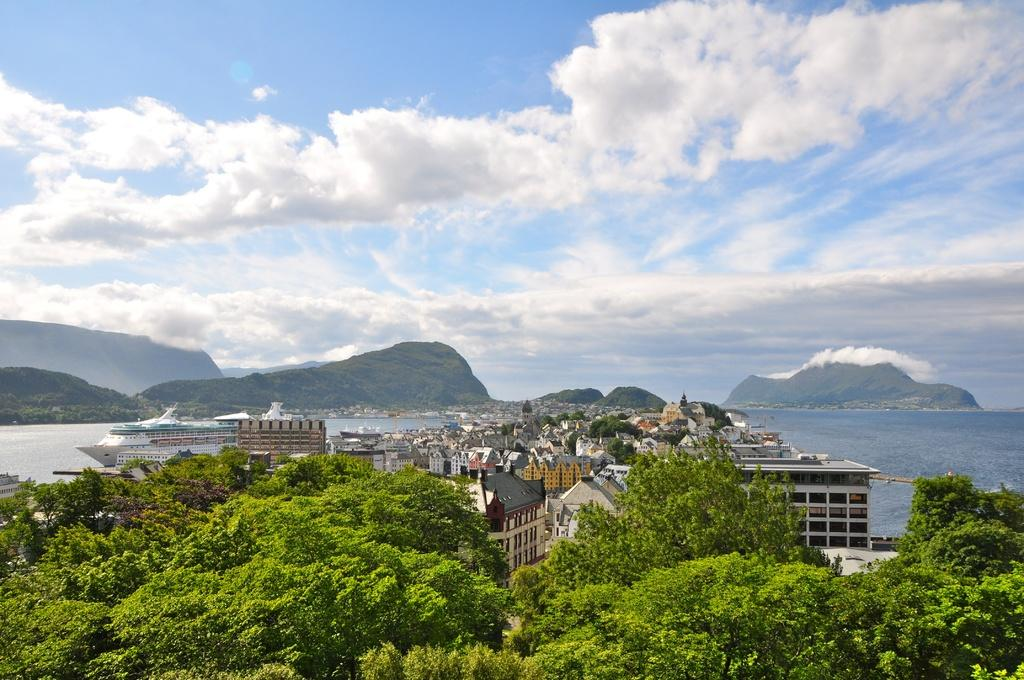What type of natural elements can be seen in the image? There are trees and mountains visible in the image. What type of man-made structures are present in the image? There are buildings in the image. What is on the water in the image? There are ships on the water in the image. What can be seen in the background of the image? Mountains, the sky, and clouds are visible in the background of the image. How many celery stalks are present in the image? There is no celery present in the image. Is there a yak visible in the image? There is no yak present in the image. 